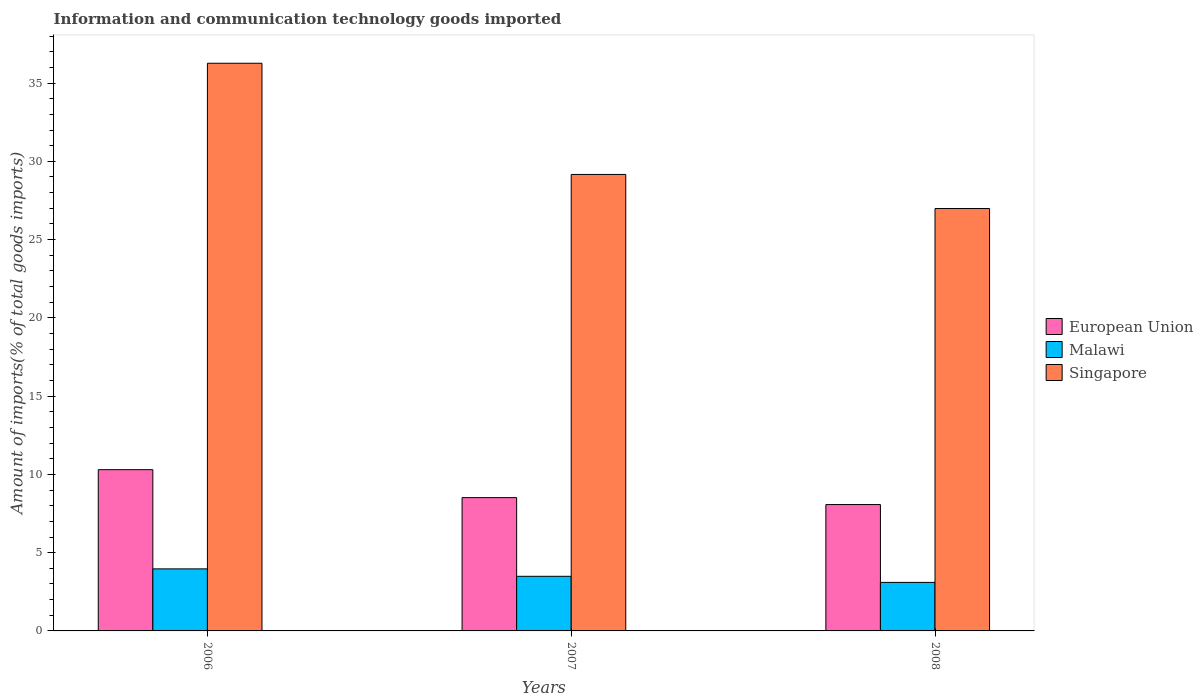How many groups of bars are there?
Provide a short and direct response. 3. Are the number of bars per tick equal to the number of legend labels?
Offer a terse response. Yes. Are the number of bars on each tick of the X-axis equal?
Ensure brevity in your answer.  Yes. How many bars are there on the 1st tick from the left?
Your response must be concise. 3. How many bars are there on the 3rd tick from the right?
Offer a terse response. 3. In how many cases, is the number of bars for a given year not equal to the number of legend labels?
Your answer should be compact. 0. What is the amount of goods imported in European Union in 2006?
Offer a terse response. 10.3. Across all years, what is the maximum amount of goods imported in Singapore?
Make the answer very short. 36.27. Across all years, what is the minimum amount of goods imported in European Union?
Your response must be concise. 8.07. In which year was the amount of goods imported in Singapore maximum?
Your answer should be very brief. 2006. In which year was the amount of goods imported in Malawi minimum?
Your answer should be very brief. 2008. What is the total amount of goods imported in Singapore in the graph?
Give a very brief answer. 92.41. What is the difference between the amount of goods imported in European Union in 2007 and that in 2008?
Make the answer very short. 0.44. What is the difference between the amount of goods imported in Singapore in 2007 and the amount of goods imported in Malawi in 2008?
Give a very brief answer. 26.06. What is the average amount of goods imported in European Union per year?
Make the answer very short. 8.96. In the year 2006, what is the difference between the amount of goods imported in Singapore and amount of goods imported in Malawi?
Your answer should be very brief. 32.3. What is the ratio of the amount of goods imported in European Union in 2006 to that in 2008?
Your answer should be very brief. 1.28. Is the amount of goods imported in European Union in 2006 less than that in 2008?
Ensure brevity in your answer.  No. What is the difference between the highest and the second highest amount of goods imported in European Union?
Your answer should be compact. 1.78. What is the difference between the highest and the lowest amount of goods imported in Malawi?
Your response must be concise. 0.86. Is the sum of the amount of goods imported in Singapore in 2006 and 2007 greater than the maximum amount of goods imported in European Union across all years?
Your response must be concise. Yes. What does the 3rd bar from the left in 2008 represents?
Your response must be concise. Singapore. What does the 2nd bar from the right in 2006 represents?
Offer a terse response. Malawi. How many years are there in the graph?
Your answer should be compact. 3. What is the difference between two consecutive major ticks on the Y-axis?
Your answer should be very brief. 5. Are the values on the major ticks of Y-axis written in scientific E-notation?
Keep it short and to the point. No. Where does the legend appear in the graph?
Ensure brevity in your answer.  Center right. What is the title of the graph?
Provide a succinct answer. Information and communication technology goods imported. What is the label or title of the Y-axis?
Your response must be concise. Amount of imports(% of total goods imports). What is the Amount of imports(% of total goods imports) in European Union in 2006?
Your answer should be compact. 10.3. What is the Amount of imports(% of total goods imports) in Malawi in 2006?
Ensure brevity in your answer.  3.96. What is the Amount of imports(% of total goods imports) of Singapore in 2006?
Your response must be concise. 36.27. What is the Amount of imports(% of total goods imports) of European Union in 2007?
Ensure brevity in your answer.  8.52. What is the Amount of imports(% of total goods imports) in Malawi in 2007?
Offer a very short reply. 3.49. What is the Amount of imports(% of total goods imports) in Singapore in 2007?
Your answer should be very brief. 29.16. What is the Amount of imports(% of total goods imports) in European Union in 2008?
Provide a short and direct response. 8.07. What is the Amount of imports(% of total goods imports) in Malawi in 2008?
Provide a succinct answer. 3.1. What is the Amount of imports(% of total goods imports) of Singapore in 2008?
Make the answer very short. 26.98. Across all years, what is the maximum Amount of imports(% of total goods imports) in European Union?
Keep it short and to the point. 10.3. Across all years, what is the maximum Amount of imports(% of total goods imports) in Malawi?
Provide a succinct answer. 3.96. Across all years, what is the maximum Amount of imports(% of total goods imports) of Singapore?
Your answer should be very brief. 36.27. Across all years, what is the minimum Amount of imports(% of total goods imports) of European Union?
Make the answer very short. 8.07. Across all years, what is the minimum Amount of imports(% of total goods imports) of Malawi?
Make the answer very short. 3.1. Across all years, what is the minimum Amount of imports(% of total goods imports) in Singapore?
Ensure brevity in your answer.  26.98. What is the total Amount of imports(% of total goods imports) of European Union in the graph?
Your response must be concise. 26.89. What is the total Amount of imports(% of total goods imports) in Malawi in the graph?
Provide a short and direct response. 10.55. What is the total Amount of imports(% of total goods imports) of Singapore in the graph?
Provide a succinct answer. 92.41. What is the difference between the Amount of imports(% of total goods imports) in European Union in 2006 and that in 2007?
Your response must be concise. 1.78. What is the difference between the Amount of imports(% of total goods imports) in Malawi in 2006 and that in 2007?
Provide a short and direct response. 0.48. What is the difference between the Amount of imports(% of total goods imports) in Singapore in 2006 and that in 2007?
Your answer should be compact. 7.1. What is the difference between the Amount of imports(% of total goods imports) in European Union in 2006 and that in 2008?
Ensure brevity in your answer.  2.23. What is the difference between the Amount of imports(% of total goods imports) in Malawi in 2006 and that in 2008?
Your answer should be very brief. 0.86. What is the difference between the Amount of imports(% of total goods imports) of Singapore in 2006 and that in 2008?
Keep it short and to the point. 9.28. What is the difference between the Amount of imports(% of total goods imports) of European Union in 2007 and that in 2008?
Make the answer very short. 0.44. What is the difference between the Amount of imports(% of total goods imports) in Malawi in 2007 and that in 2008?
Make the answer very short. 0.39. What is the difference between the Amount of imports(% of total goods imports) of Singapore in 2007 and that in 2008?
Your response must be concise. 2.18. What is the difference between the Amount of imports(% of total goods imports) in European Union in 2006 and the Amount of imports(% of total goods imports) in Malawi in 2007?
Your answer should be very brief. 6.81. What is the difference between the Amount of imports(% of total goods imports) in European Union in 2006 and the Amount of imports(% of total goods imports) in Singapore in 2007?
Provide a short and direct response. -18.86. What is the difference between the Amount of imports(% of total goods imports) in Malawi in 2006 and the Amount of imports(% of total goods imports) in Singapore in 2007?
Provide a short and direct response. -25.2. What is the difference between the Amount of imports(% of total goods imports) of European Union in 2006 and the Amount of imports(% of total goods imports) of Malawi in 2008?
Your answer should be compact. 7.2. What is the difference between the Amount of imports(% of total goods imports) of European Union in 2006 and the Amount of imports(% of total goods imports) of Singapore in 2008?
Give a very brief answer. -16.68. What is the difference between the Amount of imports(% of total goods imports) of Malawi in 2006 and the Amount of imports(% of total goods imports) of Singapore in 2008?
Your answer should be very brief. -23.02. What is the difference between the Amount of imports(% of total goods imports) in European Union in 2007 and the Amount of imports(% of total goods imports) in Malawi in 2008?
Provide a succinct answer. 5.42. What is the difference between the Amount of imports(% of total goods imports) in European Union in 2007 and the Amount of imports(% of total goods imports) in Singapore in 2008?
Your response must be concise. -18.47. What is the difference between the Amount of imports(% of total goods imports) of Malawi in 2007 and the Amount of imports(% of total goods imports) of Singapore in 2008?
Provide a succinct answer. -23.5. What is the average Amount of imports(% of total goods imports) in European Union per year?
Offer a terse response. 8.96. What is the average Amount of imports(% of total goods imports) in Malawi per year?
Offer a very short reply. 3.52. What is the average Amount of imports(% of total goods imports) in Singapore per year?
Your response must be concise. 30.8. In the year 2006, what is the difference between the Amount of imports(% of total goods imports) in European Union and Amount of imports(% of total goods imports) in Malawi?
Give a very brief answer. 6.34. In the year 2006, what is the difference between the Amount of imports(% of total goods imports) in European Union and Amount of imports(% of total goods imports) in Singapore?
Provide a succinct answer. -25.96. In the year 2006, what is the difference between the Amount of imports(% of total goods imports) in Malawi and Amount of imports(% of total goods imports) in Singapore?
Provide a succinct answer. -32.3. In the year 2007, what is the difference between the Amount of imports(% of total goods imports) in European Union and Amount of imports(% of total goods imports) in Malawi?
Ensure brevity in your answer.  5.03. In the year 2007, what is the difference between the Amount of imports(% of total goods imports) in European Union and Amount of imports(% of total goods imports) in Singapore?
Provide a succinct answer. -20.65. In the year 2007, what is the difference between the Amount of imports(% of total goods imports) in Malawi and Amount of imports(% of total goods imports) in Singapore?
Your response must be concise. -25.67. In the year 2008, what is the difference between the Amount of imports(% of total goods imports) in European Union and Amount of imports(% of total goods imports) in Malawi?
Your answer should be compact. 4.97. In the year 2008, what is the difference between the Amount of imports(% of total goods imports) in European Union and Amount of imports(% of total goods imports) in Singapore?
Give a very brief answer. -18.91. In the year 2008, what is the difference between the Amount of imports(% of total goods imports) in Malawi and Amount of imports(% of total goods imports) in Singapore?
Provide a succinct answer. -23.88. What is the ratio of the Amount of imports(% of total goods imports) of European Union in 2006 to that in 2007?
Offer a terse response. 1.21. What is the ratio of the Amount of imports(% of total goods imports) in Malawi in 2006 to that in 2007?
Keep it short and to the point. 1.14. What is the ratio of the Amount of imports(% of total goods imports) of Singapore in 2006 to that in 2007?
Offer a terse response. 1.24. What is the ratio of the Amount of imports(% of total goods imports) of European Union in 2006 to that in 2008?
Keep it short and to the point. 1.28. What is the ratio of the Amount of imports(% of total goods imports) in Malawi in 2006 to that in 2008?
Offer a terse response. 1.28. What is the ratio of the Amount of imports(% of total goods imports) in Singapore in 2006 to that in 2008?
Keep it short and to the point. 1.34. What is the ratio of the Amount of imports(% of total goods imports) of European Union in 2007 to that in 2008?
Your answer should be compact. 1.05. What is the ratio of the Amount of imports(% of total goods imports) of Malawi in 2007 to that in 2008?
Give a very brief answer. 1.13. What is the ratio of the Amount of imports(% of total goods imports) of Singapore in 2007 to that in 2008?
Make the answer very short. 1.08. What is the difference between the highest and the second highest Amount of imports(% of total goods imports) of European Union?
Your answer should be compact. 1.78. What is the difference between the highest and the second highest Amount of imports(% of total goods imports) in Malawi?
Give a very brief answer. 0.48. What is the difference between the highest and the second highest Amount of imports(% of total goods imports) in Singapore?
Provide a short and direct response. 7.1. What is the difference between the highest and the lowest Amount of imports(% of total goods imports) of European Union?
Provide a short and direct response. 2.23. What is the difference between the highest and the lowest Amount of imports(% of total goods imports) of Malawi?
Provide a short and direct response. 0.86. What is the difference between the highest and the lowest Amount of imports(% of total goods imports) of Singapore?
Provide a succinct answer. 9.28. 